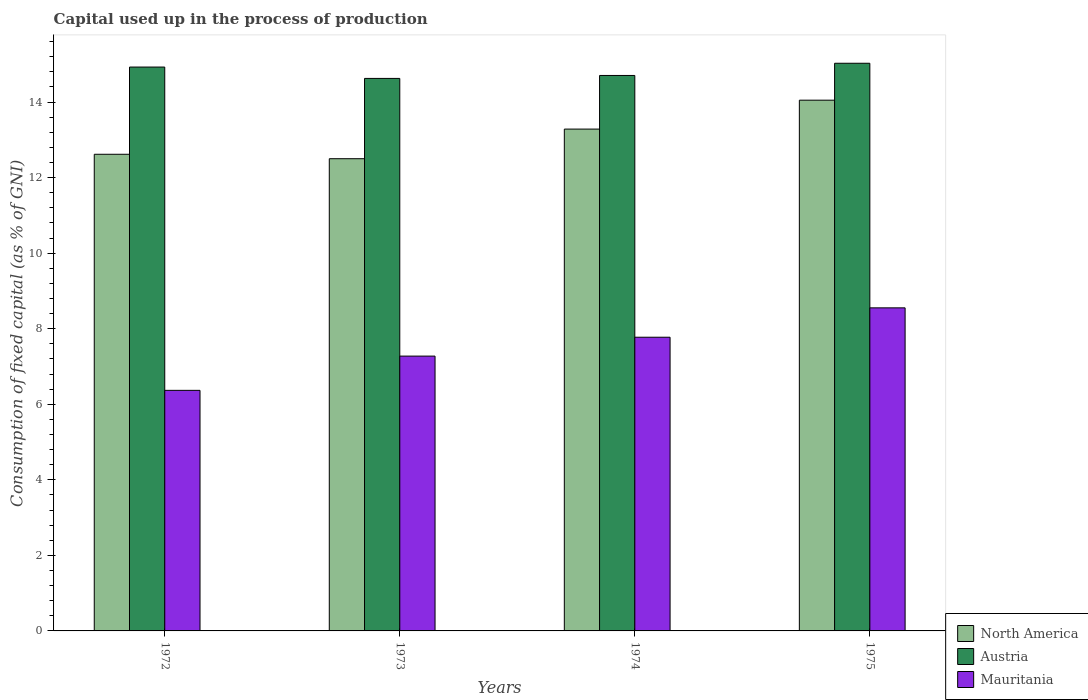How many different coloured bars are there?
Ensure brevity in your answer.  3. Are the number of bars per tick equal to the number of legend labels?
Keep it short and to the point. Yes. Are the number of bars on each tick of the X-axis equal?
Provide a short and direct response. Yes. What is the label of the 2nd group of bars from the left?
Your response must be concise. 1973. What is the capital used up in the process of production in North America in 1974?
Keep it short and to the point. 13.28. Across all years, what is the maximum capital used up in the process of production in Austria?
Keep it short and to the point. 15.03. Across all years, what is the minimum capital used up in the process of production in Austria?
Make the answer very short. 14.63. In which year was the capital used up in the process of production in North America maximum?
Ensure brevity in your answer.  1975. What is the total capital used up in the process of production in Mauritania in the graph?
Provide a succinct answer. 29.97. What is the difference between the capital used up in the process of production in North America in 1973 and that in 1974?
Make the answer very short. -0.78. What is the difference between the capital used up in the process of production in Austria in 1973 and the capital used up in the process of production in Mauritania in 1972?
Offer a terse response. 8.26. What is the average capital used up in the process of production in Mauritania per year?
Offer a very short reply. 7.49. In the year 1975, what is the difference between the capital used up in the process of production in Mauritania and capital used up in the process of production in Austria?
Keep it short and to the point. -6.47. What is the ratio of the capital used up in the process of production in North America in 1974 to that in 1975?
Your answer should be very brief. 0.95. Is the capital used up in the process of production in Mauritania in 1972 less than that in 1974?
Make the answer very short. Yes. Is the difference between the capital used up in the process of production in Mauritania in 1972 and 1973 greater than the difference between the capital used up in the process of production in Austria in 1972 and 1973?
Your answer should be very brief. No. What is the difference between the highest and the second highest capital used up in the process of production in Austria?
Offer a terse response. 0.1. What is the difference between the highest and the lowest capital used up in the process of production in North America?
Keep it short and to the point. 1.55. What does the 2nd bar from the left in 1973 represents?
Offer a very short reply. Austria. How many bars are there?
Give a very brief answer. 12. Are all the bars in the graph horizontal?
Provide a short and direct response. No. How many years are there in the graph?
Offer a very short reply. 4. What is the difference between two consecutive major ticks on the Y-axis?
Provide a succinct answer. 2. Where does the legend appear in the graph?
Make the answer very short. Bottom right. How many legend labels are there?
Ensure brevity in your answer.  3. What is the title of the graph?
Offer a very short reply. Capital used up in the process of production. What is the label or title of the Y-axis?
Your answer should be very brief. Consumption of fixed capital (as % of GNI). What is the Consumption of fixed capital (as % of GNI) of North America in 1972?
Your answer should be very brief. 12.62. What is the Consumption of fixed capital (as % of GNI) in Austria in 1972?
Give a very brief answer. 14.93. What is the Consumption of fixed capital (as % of GNI) in Mauritania in 1972?
Keep it short and to the point. 6.37. What is the Consumption of fixed capital (as % of GNI) of North America in 1973?
Provide a short and direct response. 12.5. What is the Consumption of fixed capital (as % of GNI) in Austria in 1973?
Provide a short and direct response. 14.63. What is the Consumption of fixed capital (as % of GNI) in Mauritania in 1973?
Your answer should be very brief. 7.27. What is the Consumption of fixed capital (as % of GNI) in North America in 1974?
Give a very brief answer. 13.28. What is the Consumption of fixed capital (as % of GNI) in Austria in 1974?
Provide a short and direct response. 14.7. What is the Consumption of fixed capital (as % of GNI) of Mauritania in 1974?
Provide a short and direct response. 7.77. What is the Consumption of fixed capital (as % of GNI) in North America in 1975?
Your answer should be compact. 14.05. What is the Consumption of fixed capital (as % of GNI) of Austria in 1975?
Your response must be concise. 15.03. What is the Consumption of fixed capital (as % of GNI) in Mauritania in 1975?
Give a very brief answer. 8.55. Across all years, what is the maximum Consumption of fixed capital (as % of GNI) of North America?
Keep it short and to the point. 14.05. Across all years, what is the maximum Consumption of fixed capital (as % of GNI) in Austria?
Offer a very short reply. 15.03. Across all years, what is the maximum Consumption of fixed capital (as % of GNI) in Mauritania?
Your response must be concise. 8.55. Across all years, what is the minimum Consumption of fixed capital (as % of GNI) in North America?
Provide a succinct answer. 12.5. Across all years, what is the minimum Consumption of fixed capital (as % of GNI) of Austria?
Keep it short and to the point. 14.63. Across all years, what is the minimum Consumption of fixed capital (as % of GNI) in Mauritania?
Your response must be concise. 6.37. What is the total Consumption of fixed capital (as % of GNI) of North America in the graph?
Your answer should be very brief. 52.45. What is the total Consumption of fixed capital (as % of GNI) in Austria in the graph?
Your answer should be very brief. 59.28. What is the total Consumption of fixed capital (as % of GNI) in Mauritania in the graph?
Offer a terse response. 29.97. What is the difference between the Consumption of fixed capital (as % of GNI) in North America in 1972 and that in 1973?
Provide a succinct answer. 0.12. What is the difference between the Consumption of fixed capital (as % of GNI) of Austria in 1972 and that in 1973?
Provide a short and direct response. 0.3. What is the difference between the Consumption of fixed capital (as % of GNI) of Mauritania in 1972 and that in 1973?
Your response must be concise. -0.91. What is the difference between the Consumption of fixed capital (as % of GNI) in North America in 1972 and that in 1974?
Your answer should be compact. -0.67. What is the difference between the Consumption of fixed capital (as % of GNI) in Austria in 1972 and that in 1974?
Your answer should be compact. 0.22. What is the difference between the Consumption of fixed capital (as % of GNI) in Mauritania in 1972 and that in 1974?
Offer a very short reply. -1.41. What is the difference between the Consumption of fixed capital (as % of GNI) in North America in 1972 and that in 1975?
Your response must be concise. -1.43. What is the difference between the Consumption of fixed capital (as % of GNI) in Austria in 1972 and that in 1975?
Offer a terse response. -0.1. What is the difference between the Consumption of fixed capital (as % of GNI) in Mauritania in 1972 and that in 1975?
Provide a succinct answer. -2.18. What is the difference between the Consumption of fixed capital (as % of GNI) of North America in 1973 and that in 1974?
Offer a terse response. -0.78. What is the difference between the Consumption of fixed capital (as % of GNI) of Austria in 1973 and that in 1974?
Your response must be concise. -0.08. What is the difference between the Consumption of fixed capital (as % of GNI) in Mauritania in 1973 and that in 1974?
Your answer should be very brief. -0.5. What is the difference between the Consumption of fixed capital (as % of GNI) of North America in 1973 and that in 1975?
Provide a short and direct response. -1.55. What is the difference between the Consumption of fixed capital (as % of GNI) of Austria in 1973 and that in 1975?
Provide a succinct answer. -0.4. What is the difference between the Consumption of fixed capital (as % of GNI) in Mauritania in 1973 and that in 1975?
Make the answer very short. -1.28. What is the difference between the Consumption of fixed capital (as % of GNI) of North America in 1974 and that in 1975?
Provide a short and direct response. -0.76. What is the difference between the Consumption of fixed capital (as % of GNI) of Austria in 1974 and that in 1975?
Provide a succinct answer. -0.32. What is the difference between the Consumption of fixed capital (as % of GNI) in Mauritania in 1974 and that in 1975?
Provide a short and direct response. -0.78. What is the difference between the Consumption of fixed capital (as % of GNI) in North America in 1972 and the Consumption of fixed capital (as % of GNI) in Austria in 1973?
Your response must be concise. -2.01. What is the difference between the Consumption of fixed capital (as % of GNI) of North America in 1972 and the Consumption of fixed capital (as % of GNI) of Mauritania in 1973?
Offer a very short reply. 5.34. What is the difference between the Consumption of fixed capital (as % of GNI) in Austria in 1972 and the Consumption of fixed capital (as % of GNI) in Mauritania in 1973?
Provide a short and direct response. 7.65. What is the difference between the Consumption of fixed capital (as % of GNI) of North America in 1972 and the Consumption of fixed capital (as % of GNI) of Austria in 1974?
Give a very brief answer. -2.09. What is the difference between the Consumption of fixed capital (as % of GNI) in North America in 1972 and the Consumption of fixed capital (as % of GNI) in Mauritania in 1974?
Your answer should be compact. 4.84. What is the difference between the Consumption of fixed capital (as % of GNI) of Austria in 1972 and the Consumption of fixed capital (as % of GNI) of Mauritania in 1974?
Ensure brevity in your answer.  7.15. What is the difference between the Consumption of fixed capital (as % of GNI) of North America in 1972 and the Consumption of fixed capital (as % of GNI) of Austria in 1975?
Offer a very short reply. -2.41. What is the difference between the Consumption of fixed capital (as % of GNI) of North America in 1972 and the Consumption of fixed capital (as % of GNI) of Mauritania in 1975?
Provide a short and direct response. 4.07. What is the difference between the Consumption of fixed capital (as % of GNI) in Austria in 1972 and the Consumption of fixed capital (as % of GNI) in Mauritania in 1975?
Your answer should be compact. 6.37. What is the difference between the Consumption of fixed capital (as % of GNI) of North America in 1973 and the Consumption of fixed capital (as % of GNI) of Austria in 1974?
Provide a succinct answer. -2.2. What is the difference between the Consumption of fixed capital (as % of GNI) in North America in 1973 and the Consumption of fixed capital (as % of GNI) in Mauritania in 1974?
Provide a short and direct response. 4.73. What is the difference between the Consumption of fixed capital (as % of GNI) in Austria in 1973 and the Consumption of fixed capital (as % of GNI) in Mauritania in 1974?
Ensure brevity in your answer.  6.85. What is the difference between the Consumption of fixed capital (as % of GNI) in North America in 1973 and the Consumption of fixed capital (as % of GNI) in Austria in 1975?
Provide a succinct answer. -2.53. What is the difference between the Consumption of fixed capital (as % of GNI) in North America in 1973 and the Consumption of fixed capital (as % of GNI) in Mauritania in 1975?
Offer a very short reply. 3.95. What is the difference between the Consumption of fixed capital (as % of GNI) of Austria in 1973 and the Consumption of fixed capital (as % of GNI) of Mauritania in 1975?
Keep it short and to the point. 6.07. What is the difference between the Consumption of fixed capital (as % of GNI) of North America in 1974 and the Consumption of fixed capital (as % of GNI) of Austria in 1975?
Your answer should be very brief. -1.74. What is the difference between the Consumption of fixed capital (as % of GNI) of North America in 1974 and the Consumption of fixed capital (as % of GNI) of Mauritania in 1975?
Offer a very short reply. 4.73. What is the difference between the Consumption of fixed capital (as % of GNI) of Austria in 1974 and the Consumption of fixed capital (as % of GNI) of Mauritania in 1975?
Offer a terse response. 6.15. What is the average Consumption of fixed capital (as % of GNI) of North America per year?
Give a very brief answer. 13.11. What is the average Consumption of fixed capital (as % of GNI) in Austria per year?
Make the answer very short. 14.82. What is the average Consumption of fixed capital (as % of GNI) in Mauritania per year?
Provide a short and direct response. 7.49. In the year 1972, what is the difference between the Consumption of fixed capital (as % of GNI) of North America and Consumption of fixed capital (as % of GNI) of Austria?
Give a very brief answer. -2.31. In the year 1972, what is the difference between the Consumption of fixed capital (as % of GNI) in North America and Consumption of fixed capital (as % of GNI) in Mauritania?
Ensure brevity in your answer.  6.25. In the year 1972, what is the difference between the Consumption of fixed capital (as % of GNI) of Austria and Consumption of fixed capital (as % of GNI) of Mauritania?
Ensure brevity in your answer.  8.56. In the year 1973, what is the difference between the Consumption of fixed capital (as % of GNI) in North America and Consumption of fixed capital (as % of GNI) in Austria?
Offer a terse response. -2.13. In the year 1973, what is the difference between the Consumption of fixed capital (as % of GNI) in North America and Consumption of fixed capital (as % of GNI) in Mauritania?
Provide a short and direct response. 5.23. In the year 1973, what is the difference between the Consumption of fixed capital (as % of GNI) in Austria and Consumption of fixed capital (as % of GNI) in Mauritania?
Your answer should be very brief. 7.35. In the year 1974, what is the difference between the Consumption of fixed capital (as % of GNI) in North America and Consumption of fixed capital (as % of GNI) in Austria?
Make the answer very short. -1.42. In the year 1974, what is the difference between the Consumption of fixed capital (as % of GNI) in North America and Consumption of fixed capital (as % of GNI) in Mauritania?
Make the answer very short. 5.51. In the year 1974, what is the difference between the Consumption of fixed capital (as % of GNI) of Austria and Consumption of fixed capital (as % of GNI) of Mauritania?
Your answer should be very brief. 6.93. In the year 1975, what is the difference between the Consumption of fixed capital (as % of GNI) of North America and Consumption of fixed capital (as % of GNI) of Austria?
Your answer should be compact. -0.98. In the year 1975, what is the difference between the Consumption of fixed capital (as % of GNI) of North America and Consumption of fixed capital (as % of GNI) of Mauritania?
Keep it short and to the point. 5.5. In the year 1975, what is the difference between the Consumption of fixed capital (as % of GNI) of Austria and Consumption of fixed capital (as % of GNI) of Mauritania?
Your response must be concise. 6.47. What is the ratio of the Consumption of fixed capital (as % of GNI) in North America in 1972 to that in 1973?
Your answer should be compact. 1.01. What is the ratio of the Consumption of fixed capital (as % of GNI) of Austria in 1972 to that in 1973?
Provide a short and direct response. 1.02. What is the ratio of the Consumption of fixed capital (as % of GNI) in Mauritania in 1972 to that in 1973?
Keep it short and to the point. 0.88. What is the ratio of the Consumption of fixed capital (as % of GNI) of North America in 1972 to that in 1974?
Make the answer very short. 0.95. What is the ratio of the Consumption of fixed capital (as % of GNI) in Austria in 1972 to that in 1974?
Keep it short and to the point. 1.02. What is the ratio of the Consumption of fixed capital (as % of GNI) of Mauritania in 1972 to that in 1974?
Your response must be concise. 0.82. What is the ratio of the Consumption of fixed capital (as % of GNI) of North America in 1972 to that in 1975?
Offer a terse response. 0.9. What is the ratio of the Consumption of fixed capital (as % of GNI) of Austria in 1972 to that in 1975?
Ensure brevity in your answer.  0.99. What is the ratio of the Consumption of fixed capital (as % of GNI) of Mauritania in 1972 to that in 1975?
Keep it short and to the point. 0.74. What is the ratio of the Consumption of fixed capital (as % of GNI) in North America in 1973 to that in 1974?
Ensure brevity in your answer.  0.94. What is the ratio of the Consumption of fixed capital (as % of GNI) of Mauritania in 1973 to that in 1974?
Offer a terse response. 0.94. What is the ratio of the Consumption of fixed capital (as % of GNI) of North America in 1973 to that in 1975?
Your answer should be very brief. 0.89. What is the ratio of the Consumption of fixed capital (as % of GNI) of Austria in 1973 to that in 1975?
Give a very brief answer. 0.97. What is the ratio of the Consumption of fixed capital (as % of GNI) of Mauritania in 1973 to that in 1975?
Ensure brevity in your answer.  0.85. What is the ratio of the Consumption of fixed capital (as % of GNI) of North America in 1974 to that in 1975?
Keep it short and to the point. 0.95. What is the ratio of the Consumption of fixed capital (as % of GNI) of Austria in 1974 to that in 1975?
Provide a short and direct response. 0.98. What is the ratio of the Consumption of fixed capital (as % of GNI) in Mauritania in 1974 to that in 1975?
Keep it short and to the point. 0.91. What is the difference between the highest and the second highest Consumption of fixed capital (as % of GNI) of North America?
Keep it short and to the point. 0.76. What is the difference between the highest and the second highest Consumption of fixed capital (as % of GNI) in Austria?
Make the answer very short. 0.1. What is the difference between the highest and the second highest Consumption of fixed capital (as % of GNI) of Mauritania?
Provide a short and direct response. 0.78. What is the difference between the highest and the lowest Consumption of fixed capital (as % of GNI) of North America?
Provide a short and direct response. 1.55. What is the difference between the highest and the lowest Consumption of fixed capital (as % of GNI) in Austria?
Your response must be concise. 0.4. What is the difference between the highest and the lowest Consumption of fixed capital (as % of GNI) in Mauritania?
Your answer should be compact. 2.18. 